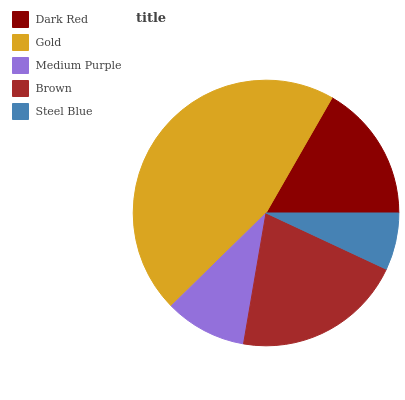Is Steel Blue the minimum?
Answer yes or no. Yes. Is Gold the maximum?
Answer yes or no. Yes. Is Medium Purple the minimum?
Answer yes or no. No. Is Medium Purple the maximum?
Answer yes or no. No. Is Gold greater than Medium Purple?
Answer yes or no. Yes. Is Medium Purple less than Gold?
Answer yes or no. Yes. Is Medium Purple greater than Gold?
Answer yes or no. No. Is Gold less than Medium Purple?
Answer yes or no. No. Is Dark Red the high median?
Answer yes or no. Yes. Is Dark Red the low median?
Answer yes or no. Yes. Is Brown the high median?
Answer yes or no. No. Is Medium Purple the low median?
Answer yes or no. No. 